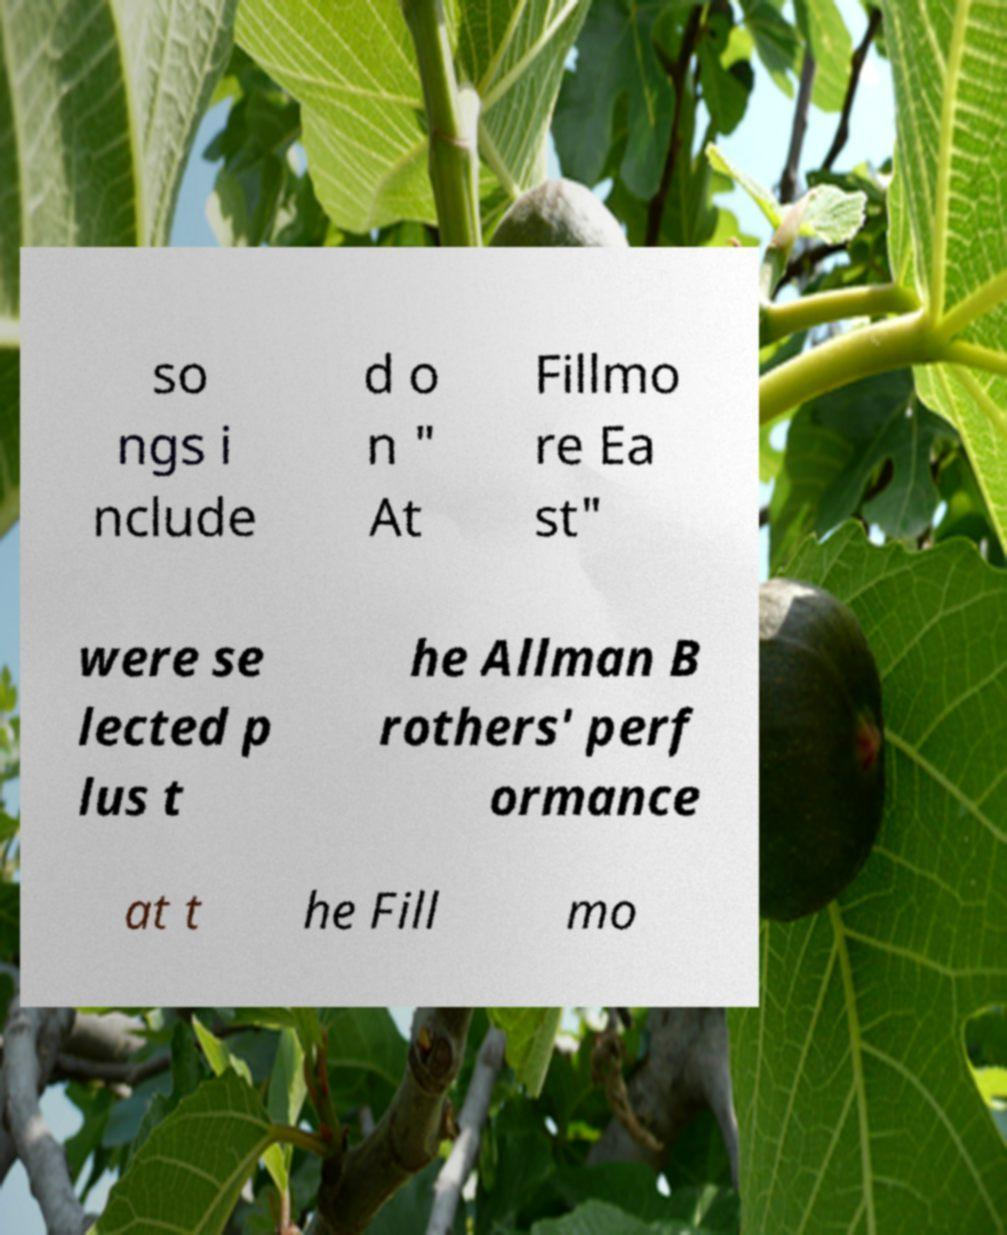Can you read and provide the text displayed in the image?This photo seems to have some interesting text. Can you extract and type it out for me? so ngs i nclude d o n " At Fillmo re Ea st" were se lected p lus t he Allman B rothers' perf ormance at t he Fill mo 